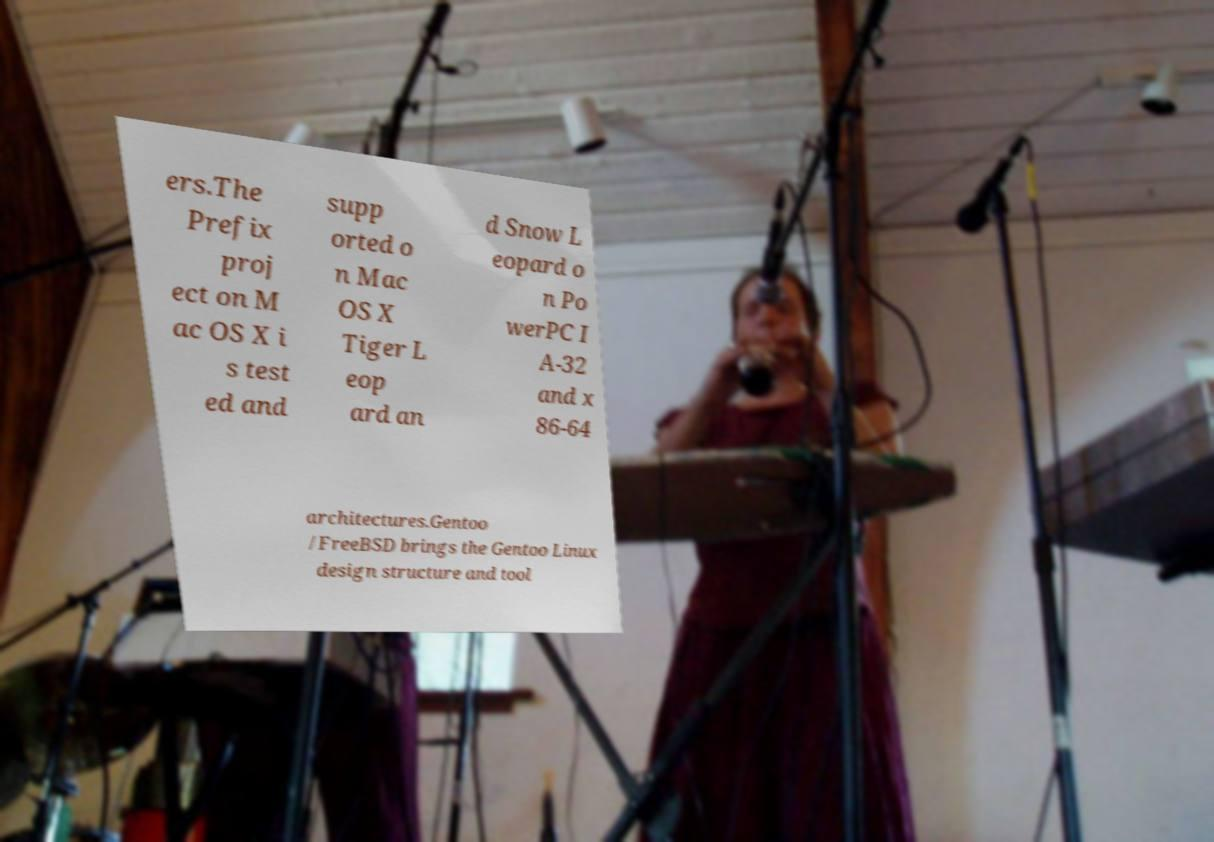Please identify and transcribe the text found in this image. ers.The Prefix proj ect on M ac OS X i s test ed and supp orted o n Mac OS X Tiger L eop ard an d Snow L eopard o n Po werPC I A-32 and x 86-64 architectures.Gentoo /FreeBSD brings the Gentoo Linux design structure and tool 